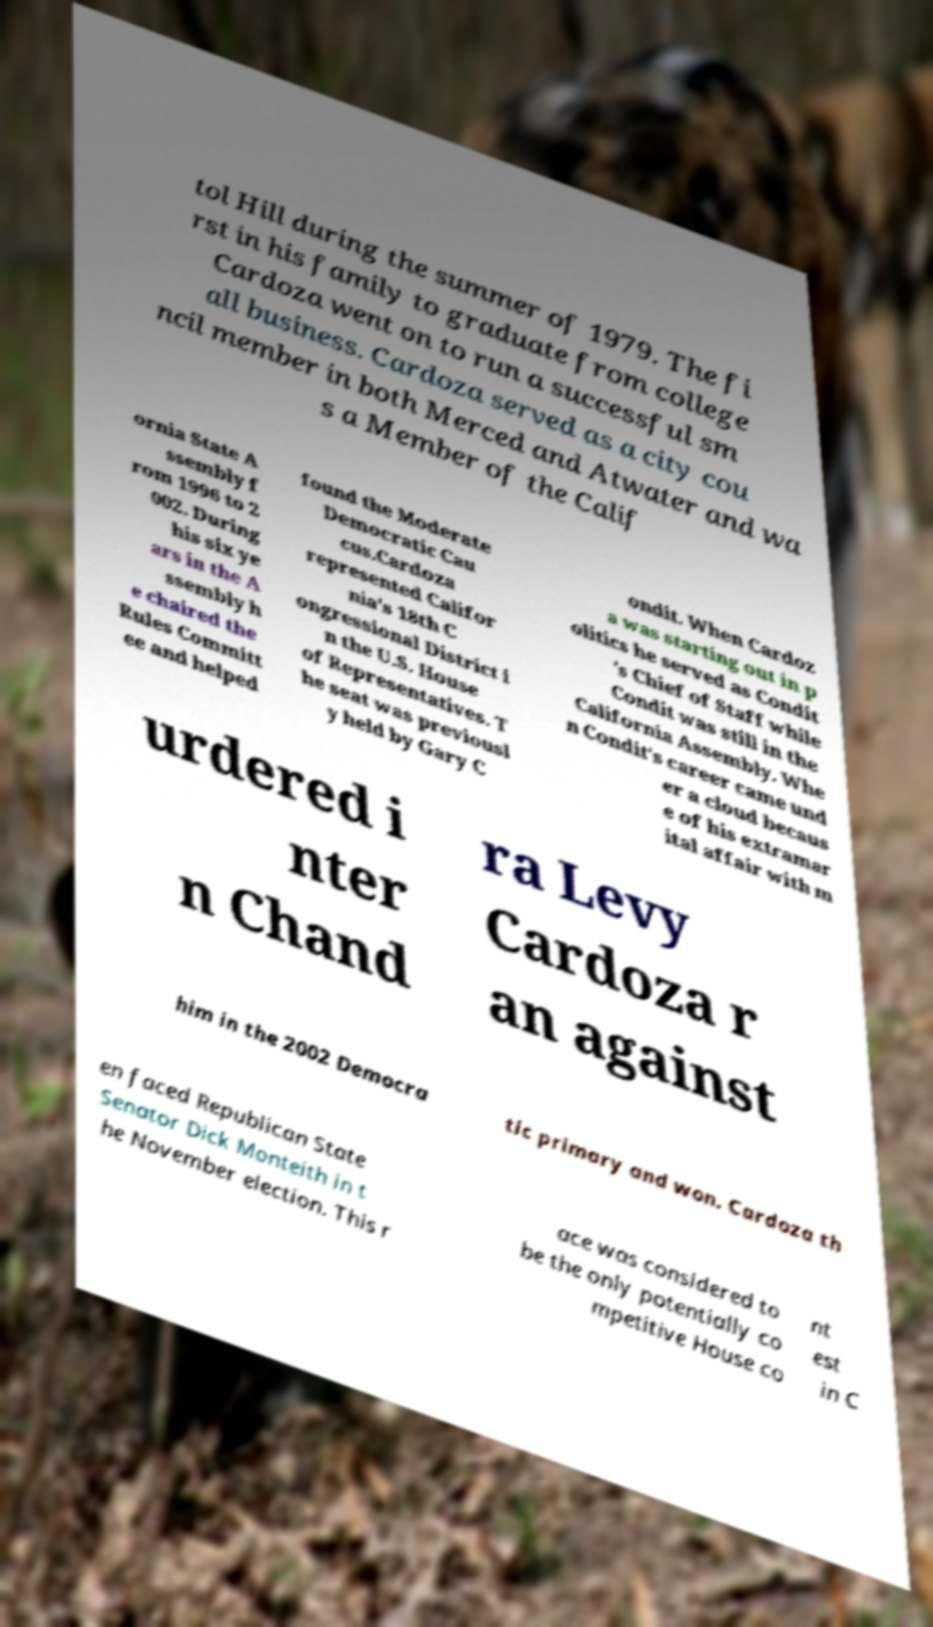There's text embedded in this image that I need extracted. Can you transcribe it verbatim? tol Hill during the summer of 1979. The fi rst in his family to graduate from college Cardoza went on to run a successful sm all business. Cardoza served as a city cou ncil member in both Merced and Atwater and wa s a Member of the Calif ornia State A ssembly f rom 1996 to 2 002. During his six ye ars in the A ssembly h e chaired the Rules Committ ee and helped found the Moderate Democratic Cau cus.Cardoza represented Califor nia's 18th C ongressional District i n the U.S. House of Representatives. T he seat was previousl y held by Gary C ondit. When Cardoz a was starting out in p olitics he served as Condit 's Chief of Staff while Condit was still in the California Assembly. Whe n Condit's career came und er a cloud becaus e of his extramar ital affair with m urdered i nter n Chand ra Levy Cardoza r an against him in the 2002 Democra tic primary and won. Cardoza th en faced Republican State Senator Dick Monteith in t he November election. This r ace was considered to be the only potentially co mpetitive House co nt est in C 